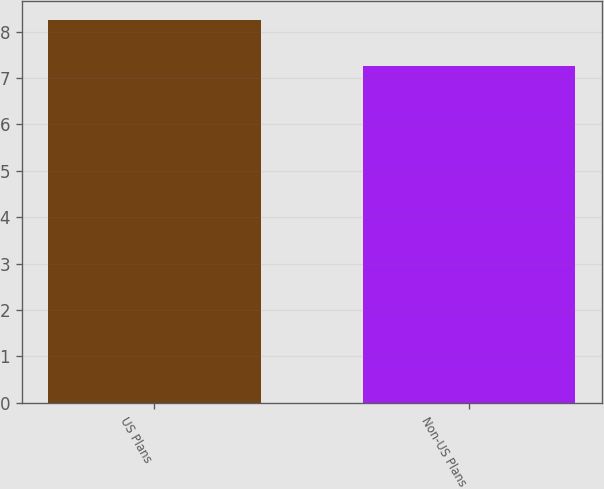Convert chart. <chart><loc_0><loc_0><loc_500><loc_500><bar_chart><fcel>US Plans<fcel>Non-US Plans<nl><fcel>8.25<fcel>7.25<nl></chart> 